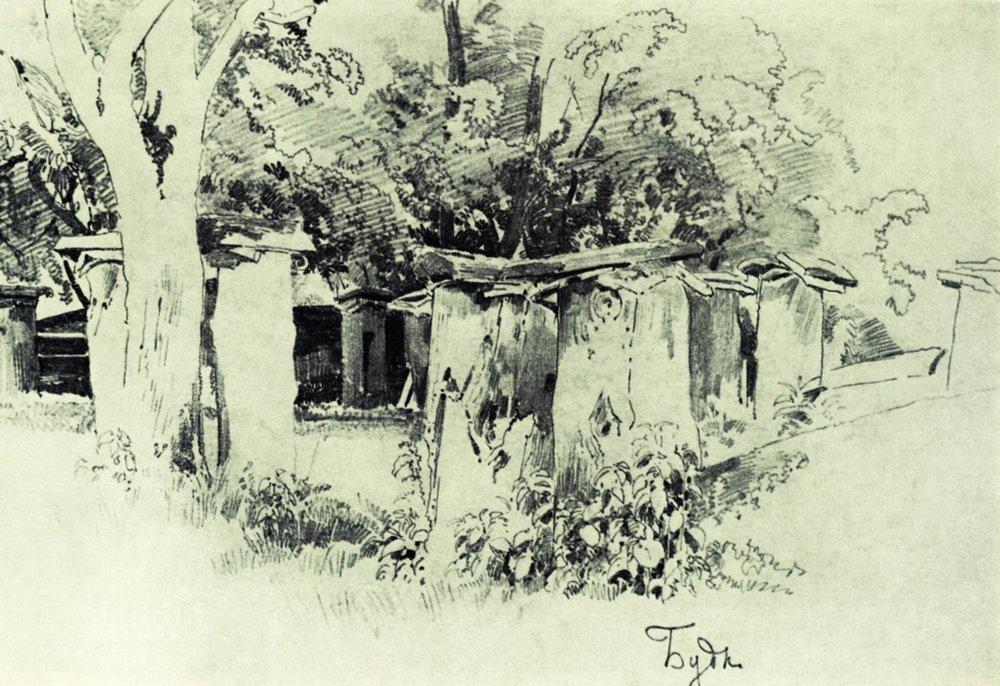Who might live in these houses? The houses in this picturesque rural scene might be home to a community of villagers who live a simple and peaceful life. These people are likely families of farmers, artisans, and craftsmen who work the land and create beautiful hand-made goods. Their days are filled with hard work, but also with a strong sense of community and belonging, as they gather for communal meals and village celebrations. What kind of festivals might they celebrate here? In this quaint village, the community might celebrate several colorful and joyous festivals throughout the year. One such festival could be the Harvest Festival, where villagers gather to celebrate the bountiful crops they have grown. The day would be filled with music, dancing, and feasting on freshly prepared dishes made from the harvest. Another festival might be the Spring Blossom Festival, marking the arrival of spring with the blooming of the trees and flowers. Villagers would decorate their homes with blossoms, hold a parade through the village, and conclude with a communal bonfire as a symbol of new beginnings. Imagine a historical event that took place in this setting. Describe how it might have unfolded. Long ago, this serene village was the site of a significant historical event known as the Great Tree Council. During a time of unrest and conflict between neighboring villages, the elders of this village decided to host a council meeting under the ancient trees to seek a peaceful resolution. Delegates from the surrounding areas were invited, each bringing gifts of their region’s best produce and crafts to symbolize their willingness to cooperate. Over several days, the delegates, guided by the wisdom of the village’s elders, engaged in discussions and negotiations. The cool shade of the trees provided a tranquil setting, helping to ease tensions and foster mutual understanding. Ultimately, the council resulted in the signing of a peace treaty, ensuring years of harmony and cooperation. This event became a cornerstone of the village’s history, celebrated annually with a reenactment and the planting of a new tree to symbolize ongoing peace and unity. What would happen if the trees could talk? If the trees in this tranquil setting could talk, they would share tales of centuries past, whispering secrets of the village’s history and the many generations that have come and gone. They might tell stories of children playing beneath their branches, of lovers carving their initials into their bark, and of the village’s festivals and celebrations. The trees would offer wisdom and guidance, reminding the villagers of the importance of living in harmony with nature and each other. Their deep, resonant voices would be like a gentle rustle of leaves, calming and grounding anyone who stopped to listen. In times of trouble, the talking trees could provide comfort, recounting the resilience of the village and offering hope for the future. 